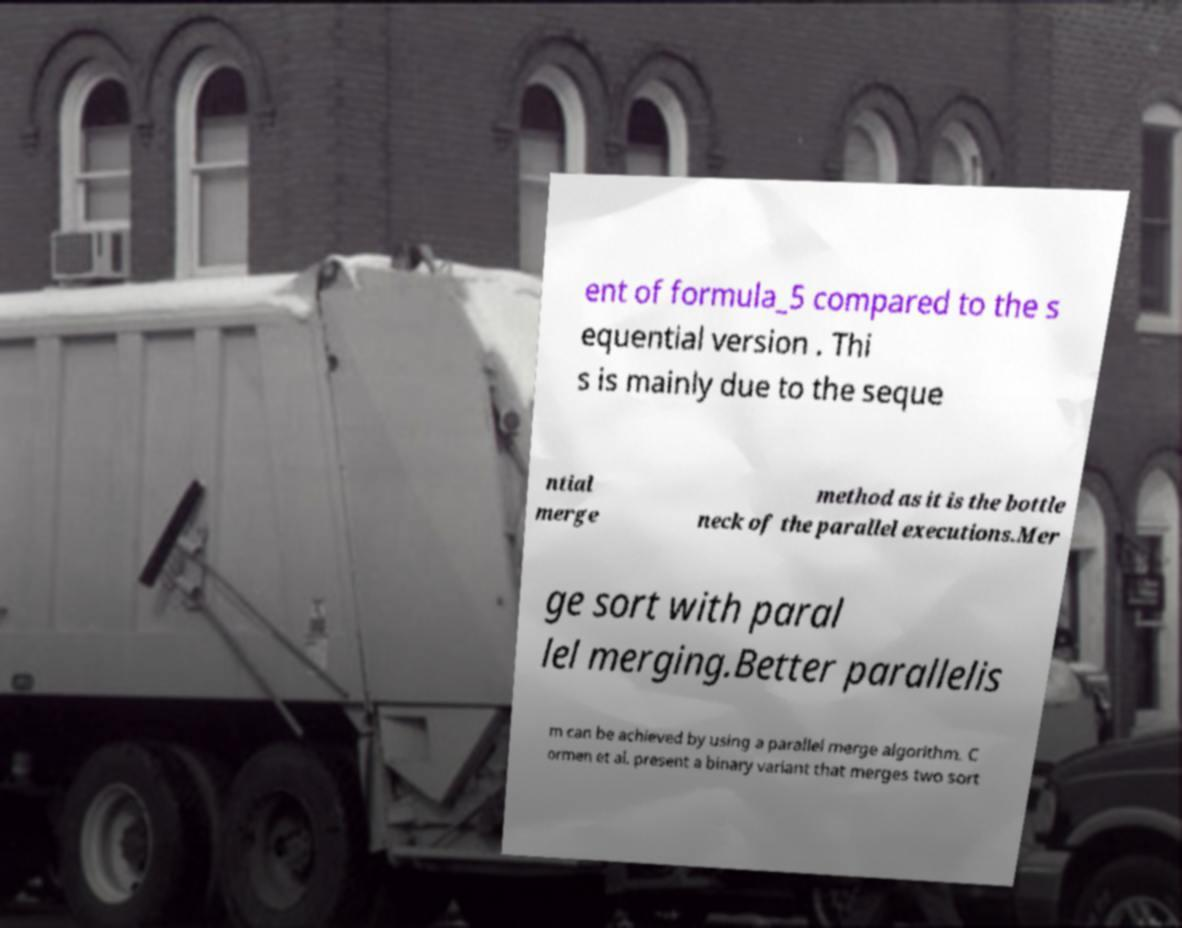For documentation purposes, I need the text within this image transcribed. Could you provide that? ent of formula_5 compared to the s equential version . Thi s is mainly due to the seque ntial merge method as it is the bottle neck of the parallel executions.Mer ge sort with paral lel merging.Better parallelis m can be achieved by using a parallel merge algorithm. C ormen et al. present a binary variant that merges two sort 